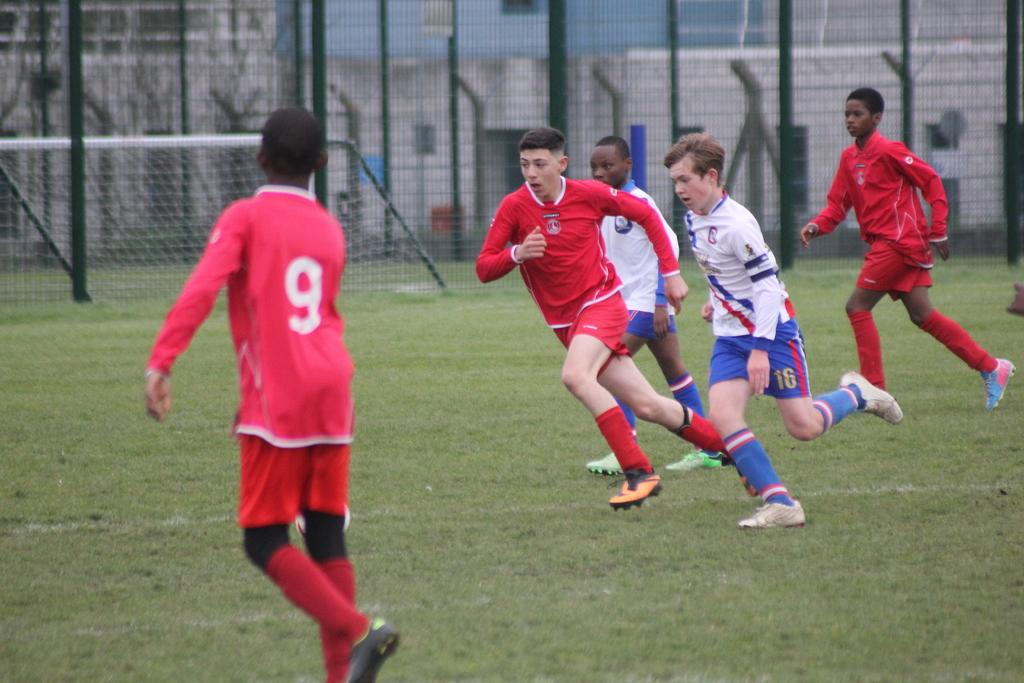How many people are in the image? There is a group of people in the image. What are the people in the image doing? The people are running on the grass. What can be seen in the background of the image? There are buildings, a fence, poles, and a football goal post in the background of the image. What type of cloth is being used by the band in the image? There is no band present in the image, so there is no cloth being used by a band. 